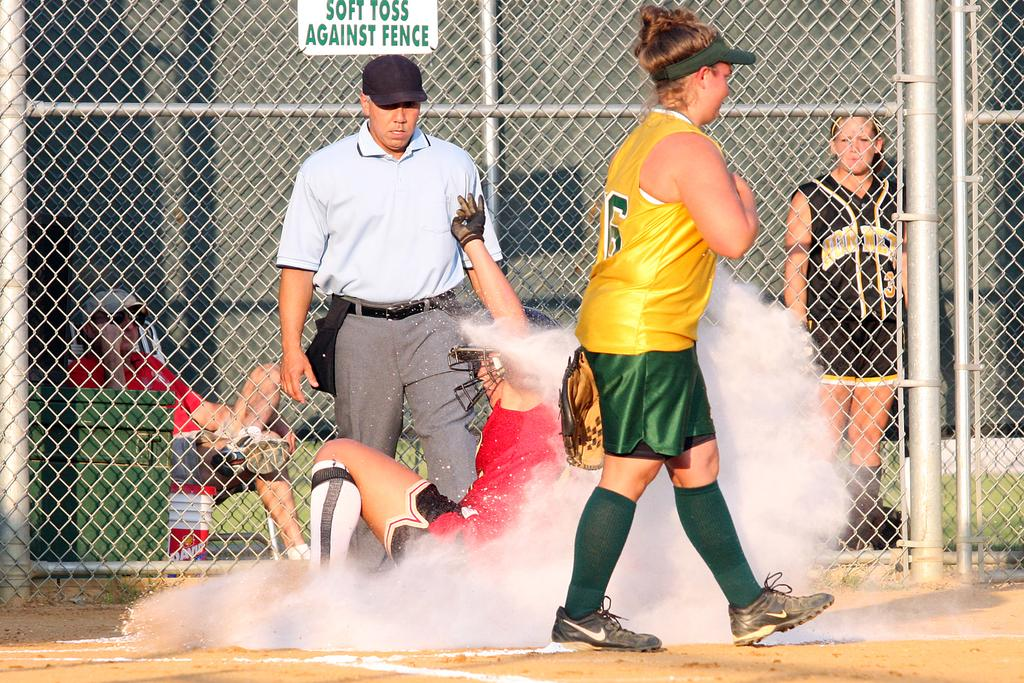<image>
Relay a brief, clear account of the picture shown. A player slides home during a softball game near a fence with a sign that reads SOFT TOSS AGAINST FENCE. 